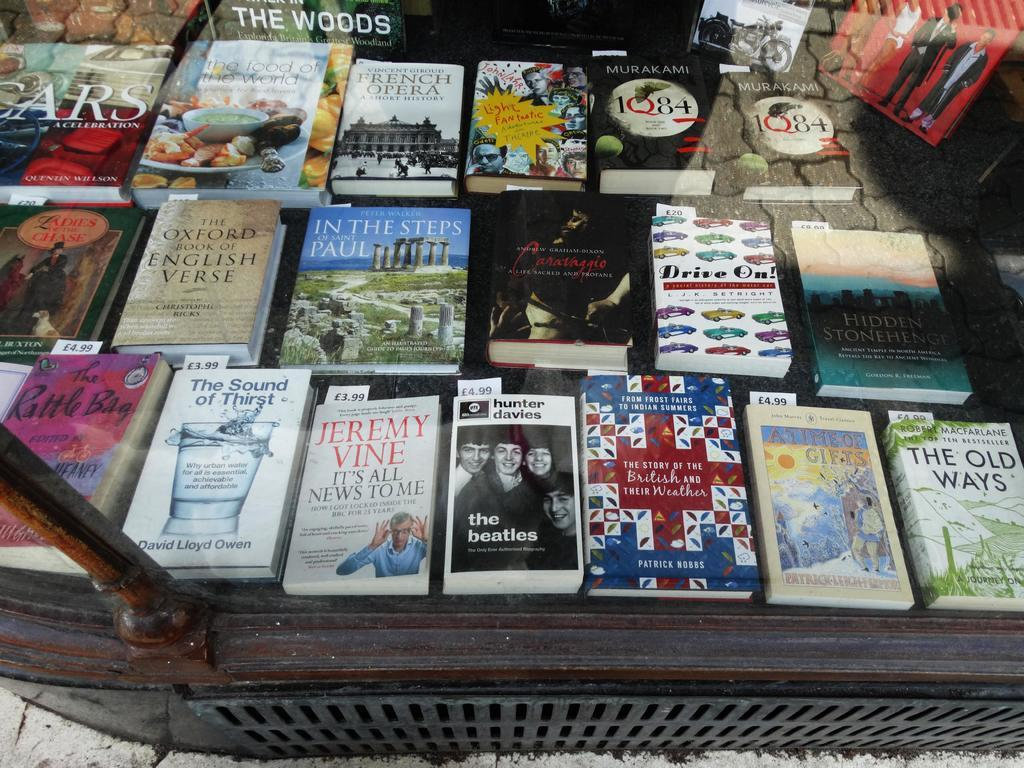<image>
Give a short and clear explanation of the subsequent image. Hunter Davies' book about The Beatles costs 4.99. 